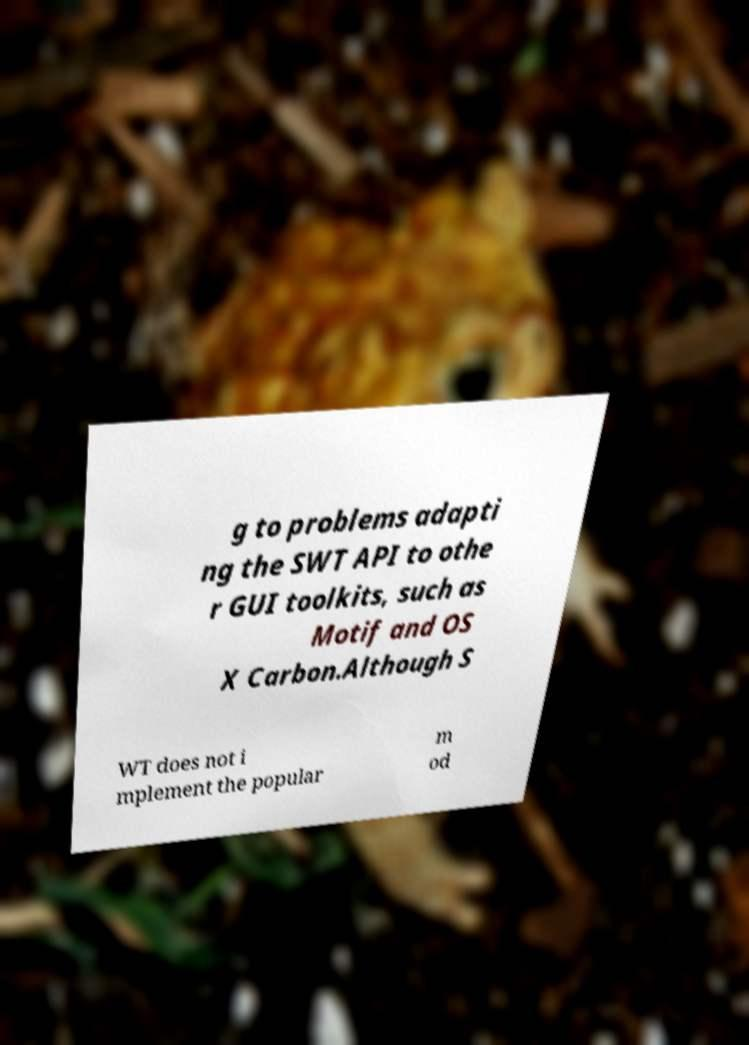What messages or text are displayed in this image? I need them in a readable, typed format. g to problems adapti ng the SWT API to othe r GUI toolkits, such as Motif and OS X Carbon.Although S WT does not i mplement the popular m od 